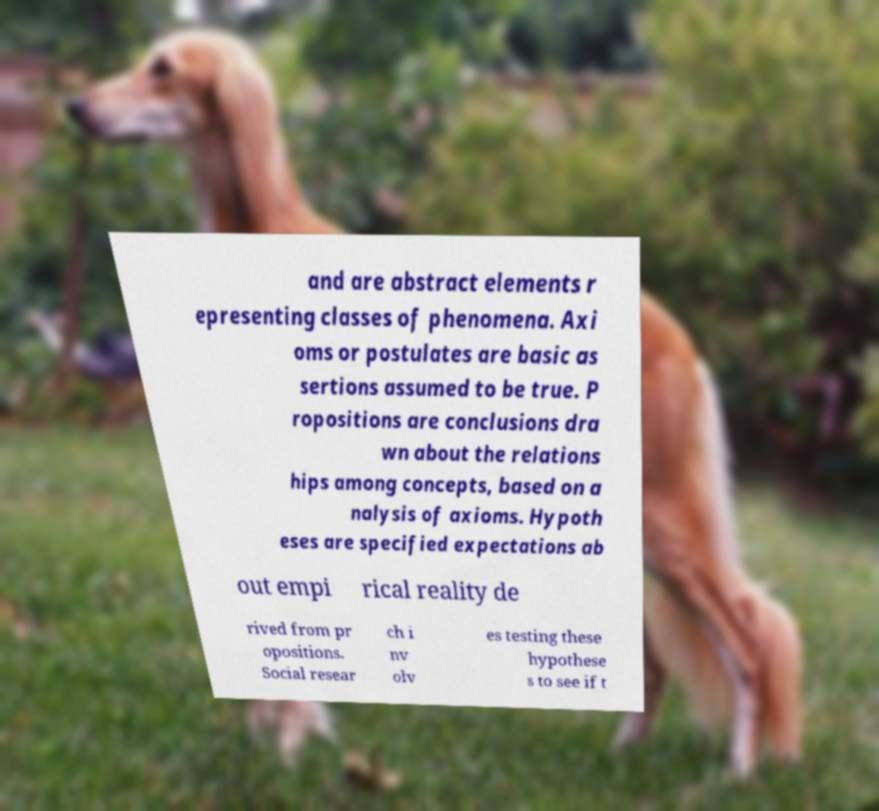I need the written content from this picture converted into text. Can you do that? and are abstract elements r epresenting classes of phenomena. Axi oms or postulates are basic as sertions assumed to be true. P ropositions are conclusions dra wn about the relations hips among concepts, based on a nalysis of axioms. Hypoth eses are specified expectations ab out empi rical reality de rived from pr opositions. Social resear ch i nv olv es testing these hypothese s to see if t 